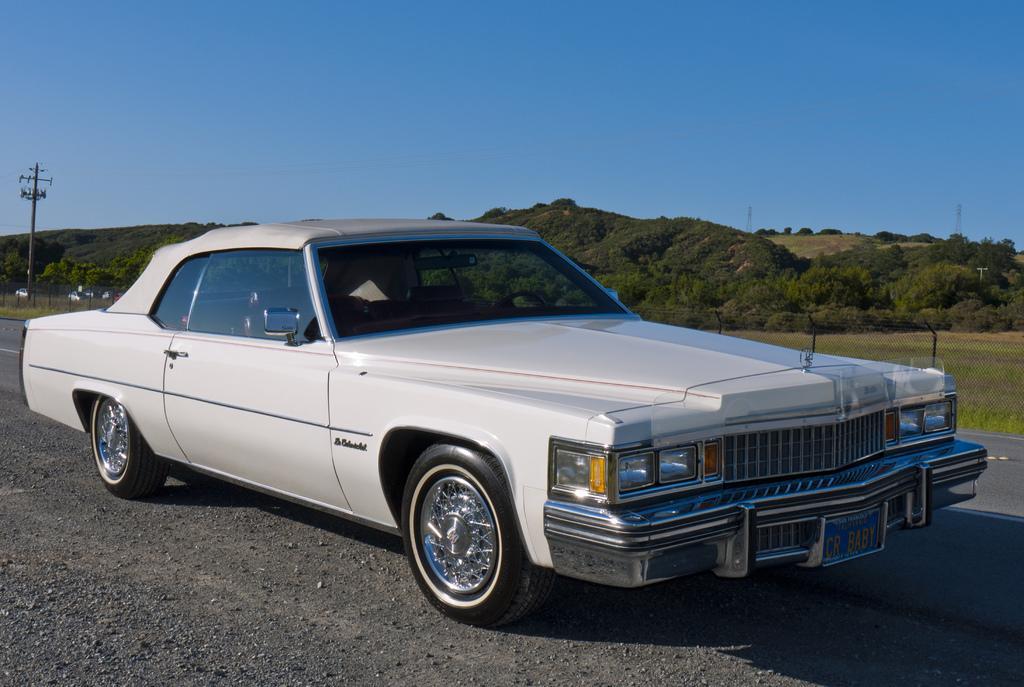How would you summarize this image in a sentence or two? In this image we can see a car on the road. Behind the car, pole and pants are there. At the top of the image blue color sky is present. 